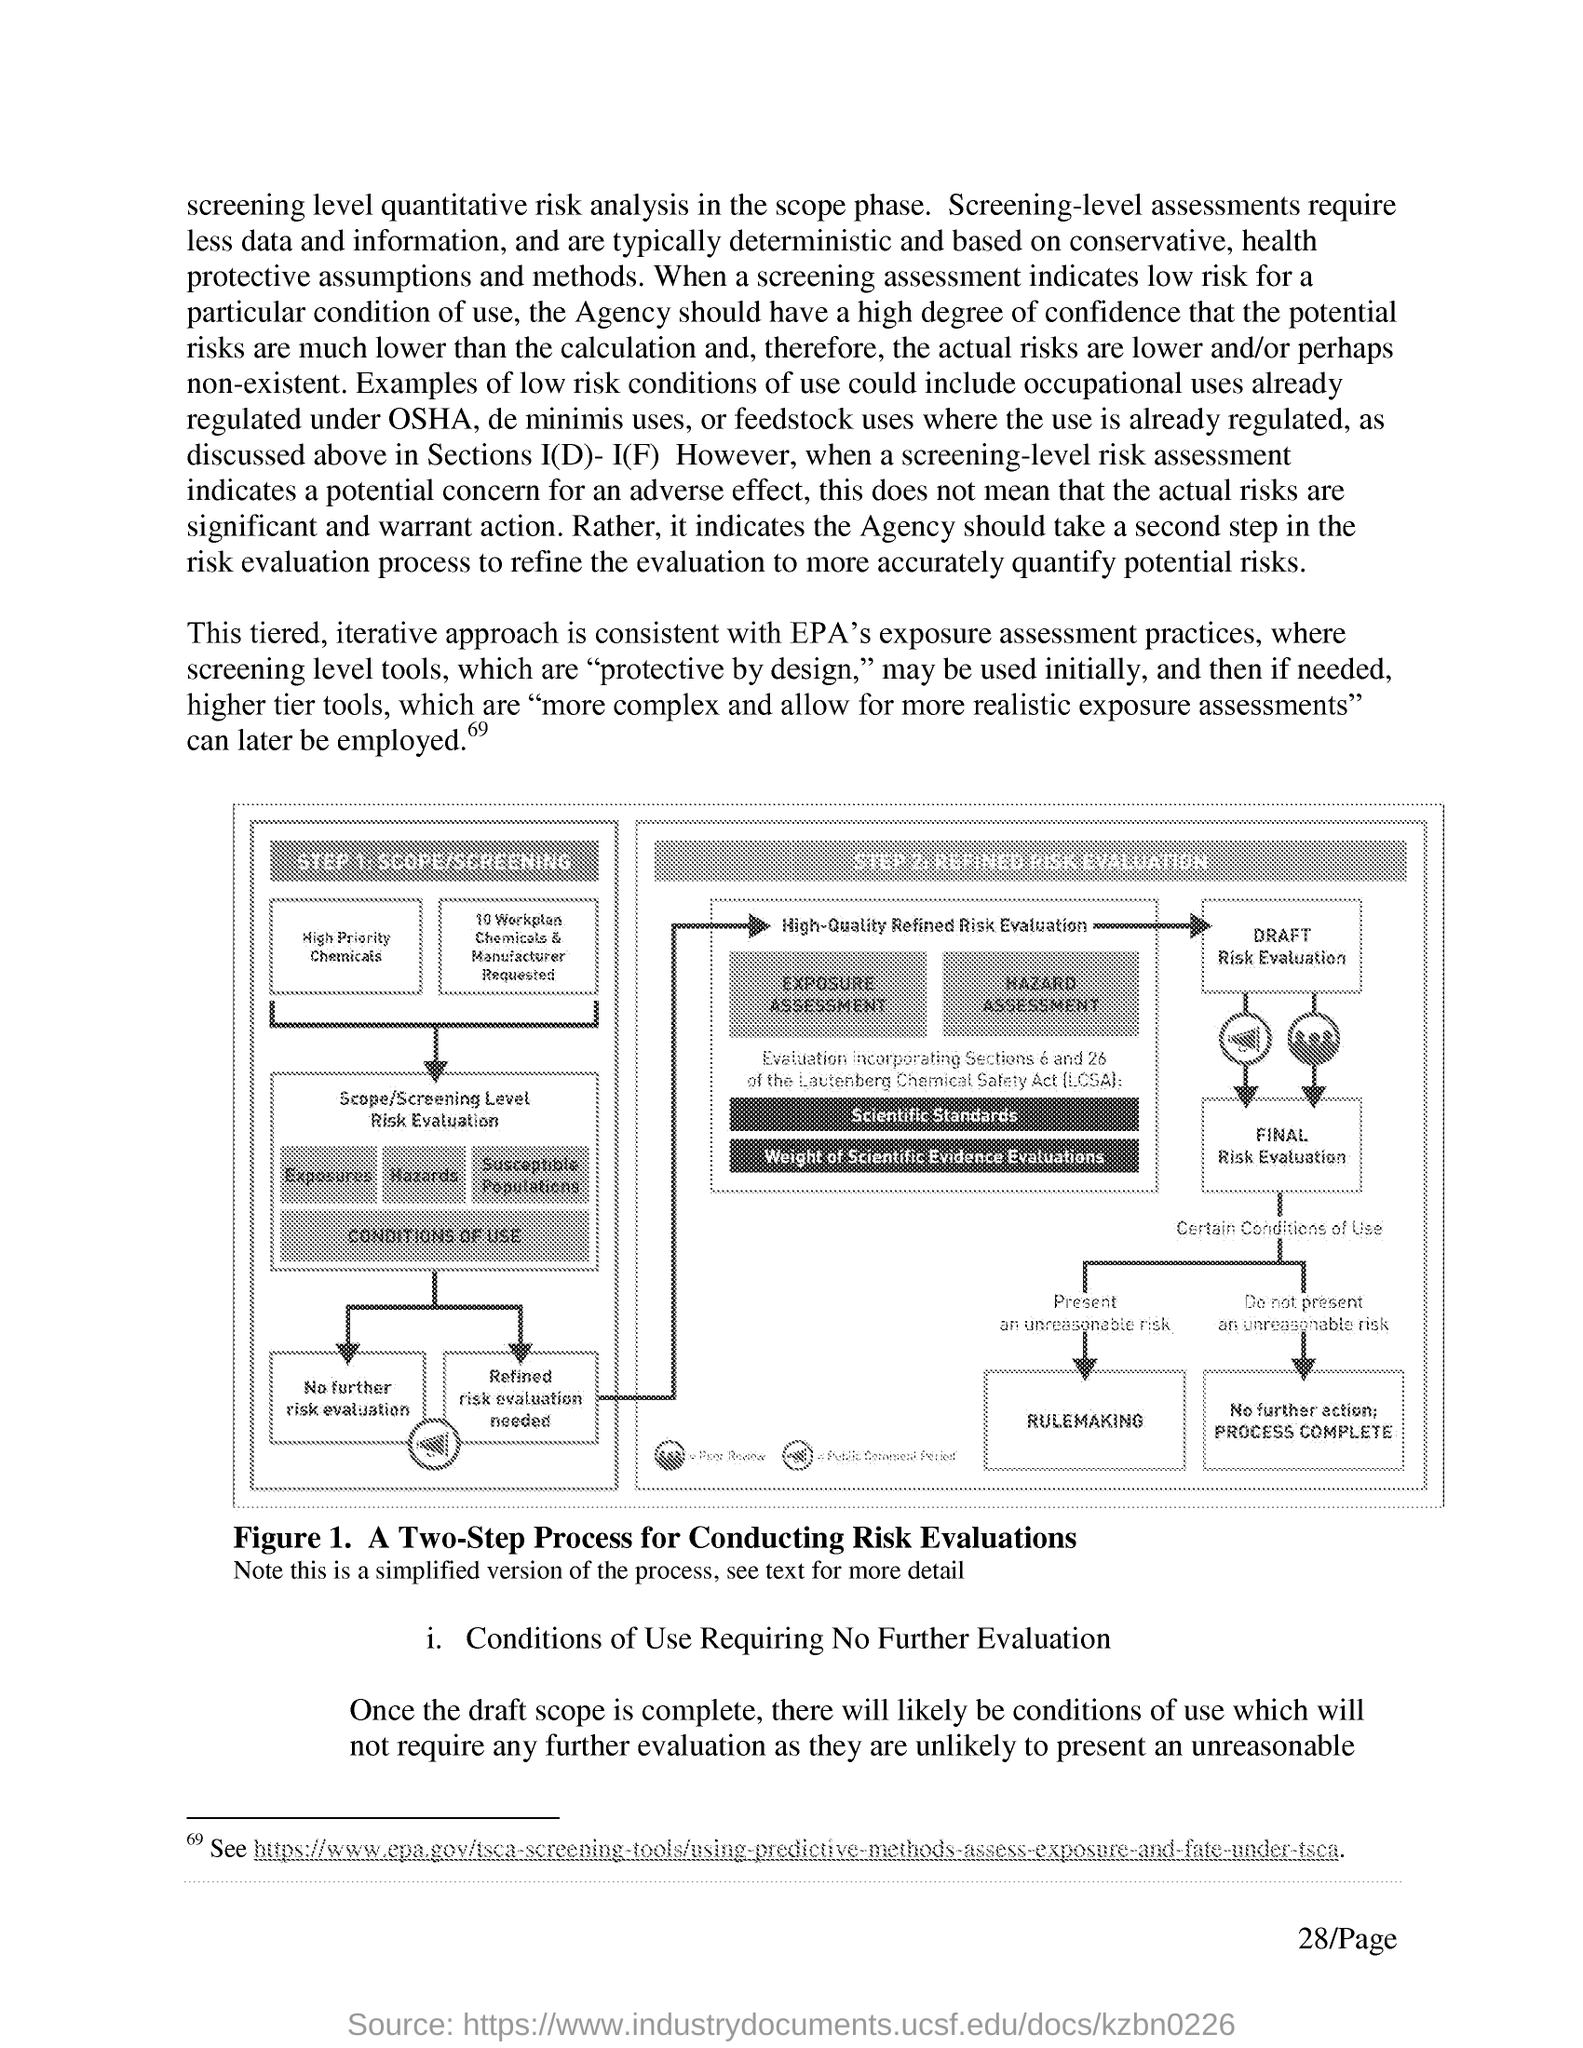What does Figure 1. in this document depict?
Your answer should be very brief. A Two-Step Process for Conducting Risk Evaluations. What is Step 1. for conducting the risk evaluation?
Give a very brief answer. Scope/screening. What is Step 2. for conducting the risk evaluation?
Provide a succinct answer. Refined risk evaluation. 